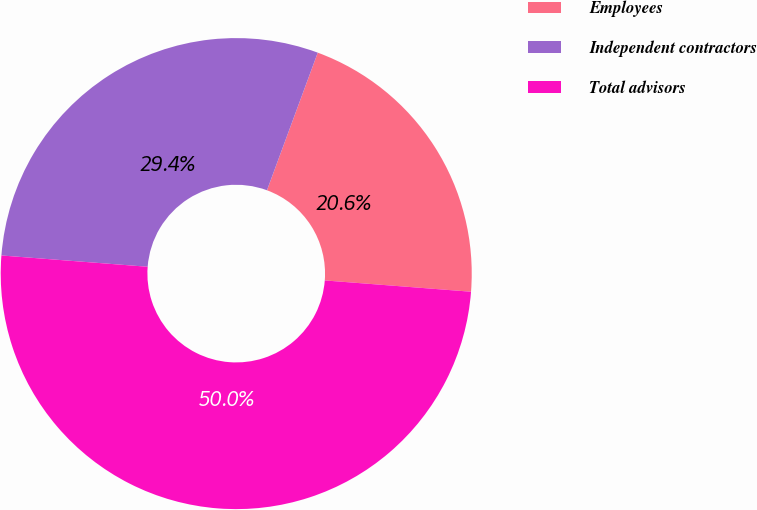Convert chart to OTSL. <chart><loc_0><loc_0><loc_500><loc_500><pie_chart><fcel>Employees<fcel>Independent contractors<fcel>Total advisors<nl><fcel>20.6%<fcel>29.4%<fcel>50.0%<nl></chart> 